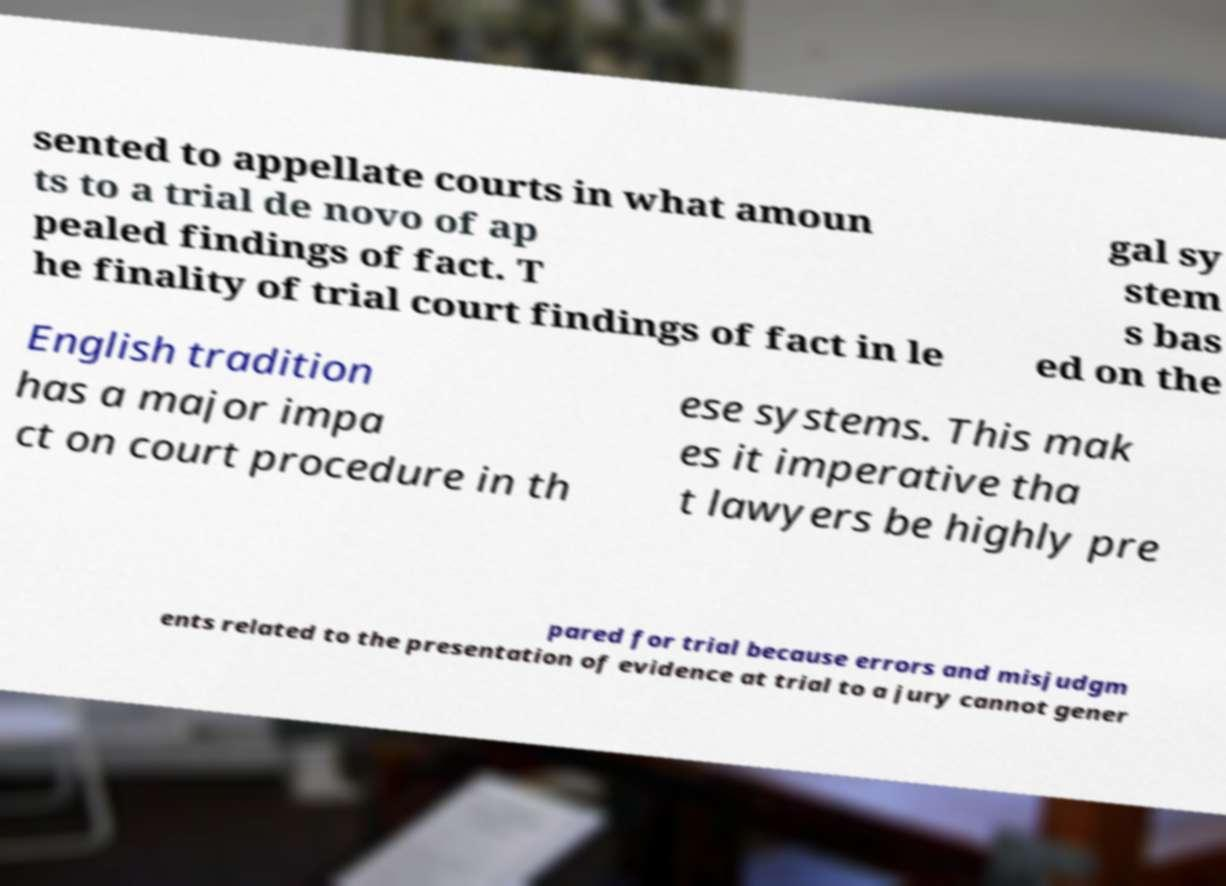Please read and relay the text visible in this image. What does it say? sented to appellate courts in what amoun ts to a trial de novo of ap pealed findings of fact. T he finality of trial court findings of fact in le gal sy stem s bas ed on the English tradition has a major impa ct on court procedure in th ese systems. This mak es it imperative tha t lawyers be highly pre pared for trial because errors and misjudgm ents related to the presentation of evidence at trial to a jury cannot gener 